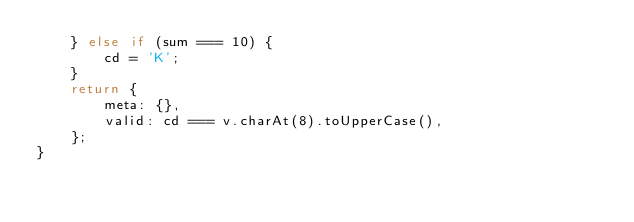<code> <loc_0><loc_0><loc_500><loc_500><_TypeScript_>    } else if (sum === 10) {
        cd = 'K';
    }
    return {
        meta: {},
        valid: cd === v.charAt(8).toUpperCase(),
    };
}
</code> 